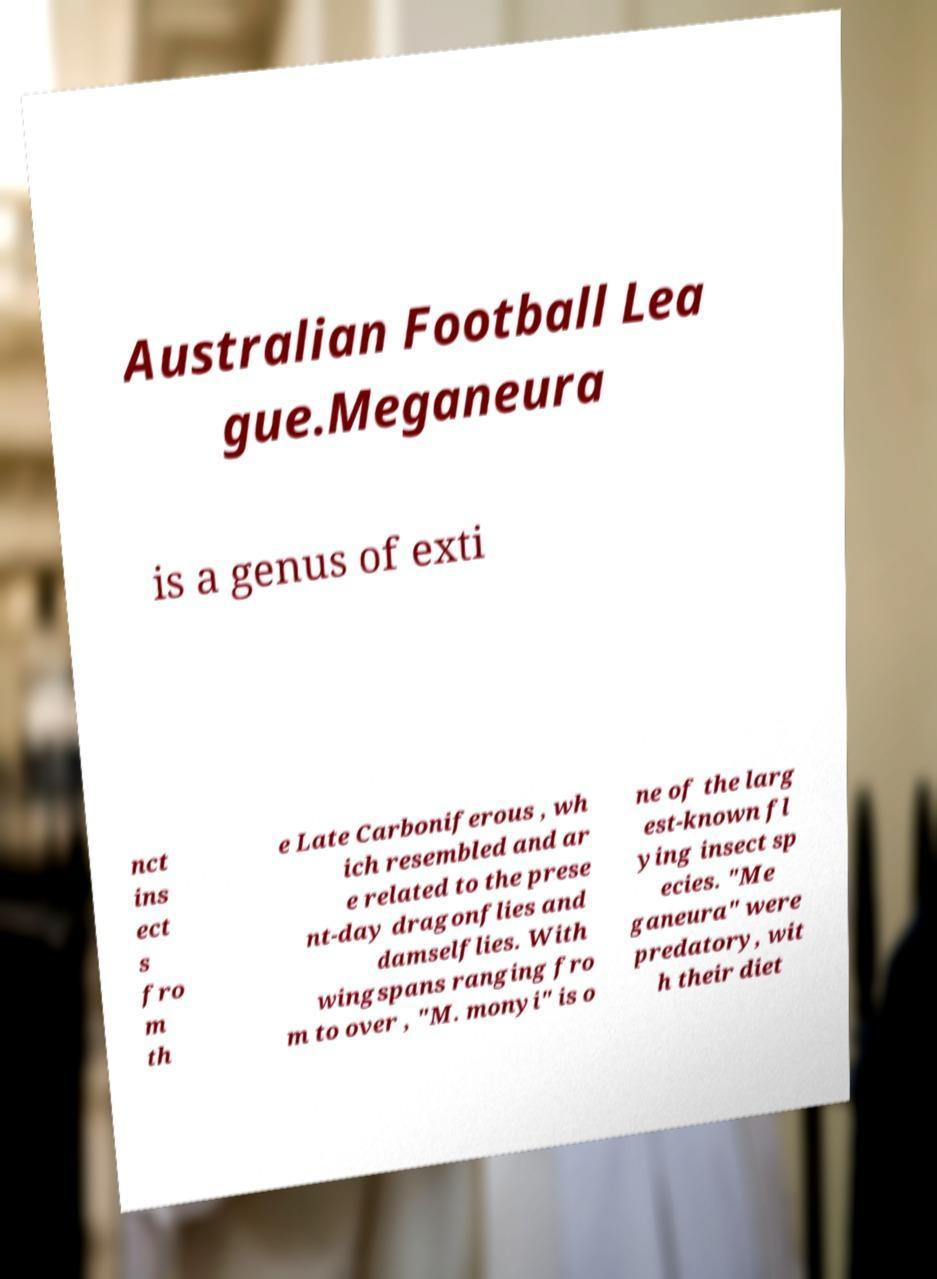What messages or text are displayed in this image? I need them in a readable, typed format. Australian Football Lea gue.Meganeura is a genus of exti nct ins ect s fro m th e Late Carboniferous , wh ich resembled and ar e related to the prese nt-day dragonflies and damselflies. With wingspans ranging fro m to over , "M. monyi" is o ne of the larg est-known fl ying insect sp ecies. "Me ganeura" were predatory, wit h their diet 